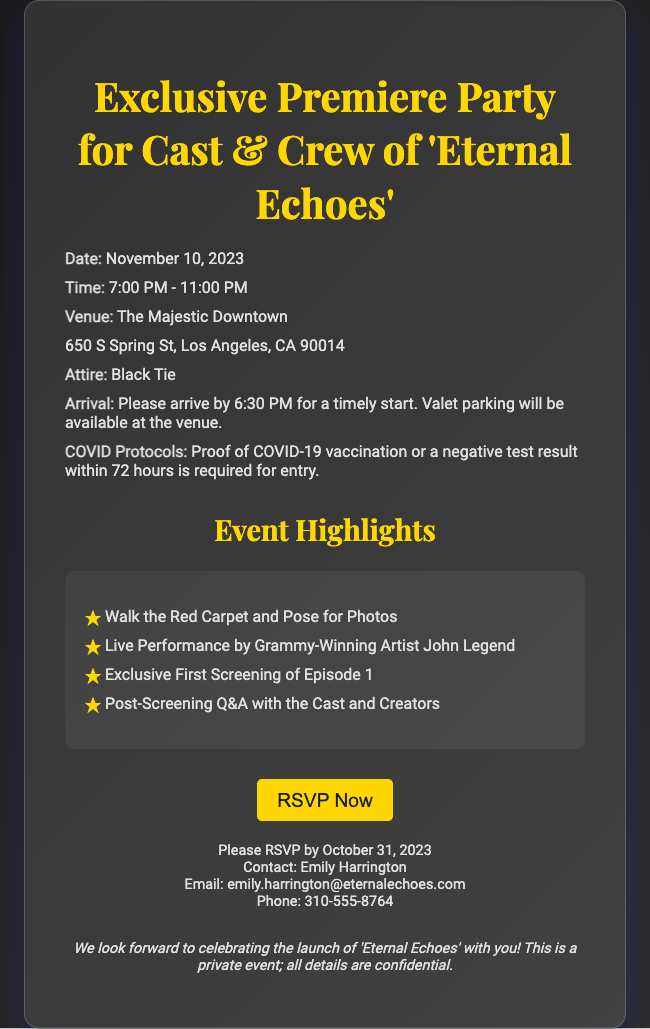what is the event date? The event date is specifically mentioned in the document.
Answer: November 10, 2023 what time does the party start? The starting time of the party is clearly stated in the schedule.
Answer: 7:00 PM where is the venue located? The venue address is provided in the document.
Answer: The Majestic Downtown, 650 S Spring St, Los Angeles, CA 90014 what is the attire for the event? The document specifies the required dress code for attendees.
Answer: Black Tie what is required for entry? Entry requirements are outlined in the COVID protocols section.
Answer: Proof of COVID-19 vaccination or a negative test result within 72 hours how long is the event scheduled to last? The length of the event can be calculated from the start and end times mentioned.
Answer: 4 hours who is performing live at the event? The document lists the artist performing live.
Answer: John Legend by when should RSVPs be submitted? The RSVP deadline is mentioned in the contact information.
Answer: October 31, 2023 what activity takes place after the screening? The document describes what happens post-screening.
Answer: Post-Screening Q&A with the Cast and Creators 